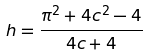<formula> <loc_0><loc_0><loc_500><loc_500>h = \frac { \pi ^ { 2 } + 4 c ^ { 2 } - 4 } { 4 c + 4 }</formula> 